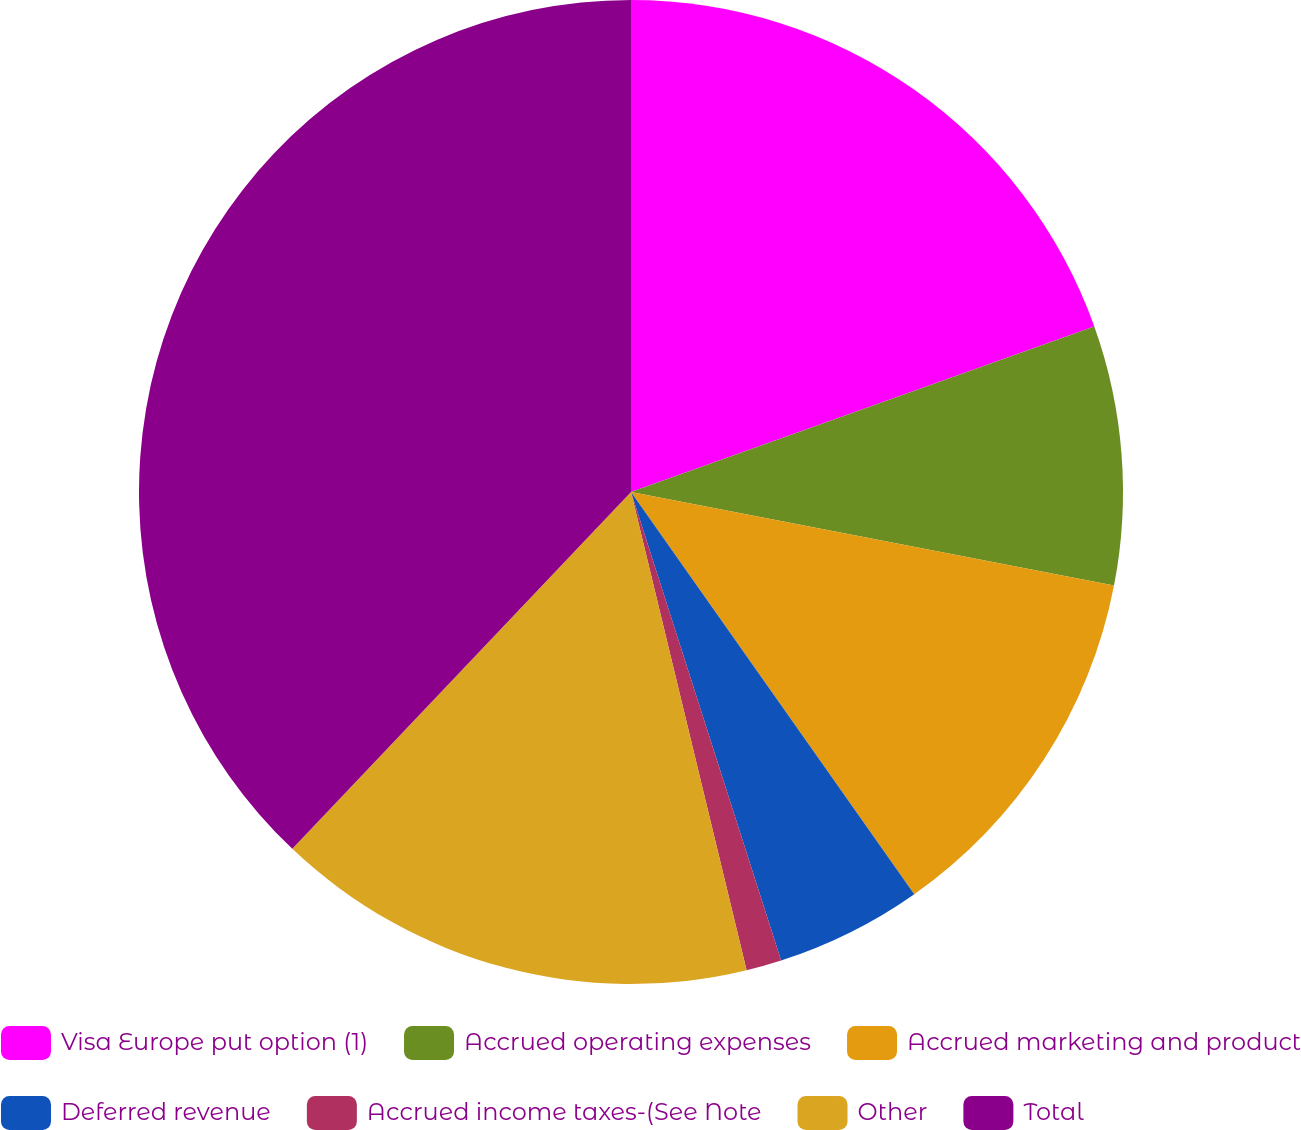Convert chart. <chart><loc_0><loc_0><loc_500><loc_500><pie_chart><fcel>Visa Europe put option (1)<fcel>Accrued operating expenses<fcel>Accrued marketing and product<fcel>Deferred revenue<fcel>Accrued income taxes-(See Note<fcel>Other<fcel>Total<nl><fcel>19.54%<fcel>8.51%<fcel>12.19%<fcel>4.83%<fcel>1.16%<fcel>15.86%<fcel>37.92%<nl></chart> 